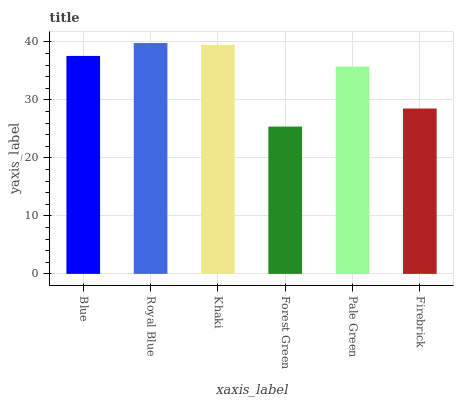Is Forest Green the minimum?
Answer yes or no. Yes. Is Royal Blue the maximum?
Answer yes or no. Yes. Is Khaki the minimum?
Answer yes or no. No. Is Khaki the maximum?
Answer yes or no. No. Is Royal Blue greater than Khaki?
Answer yes or no. Yes. Is Khaki less than Royal Blue?
Answer yes or no. Yes. Is Khaki greater than Royal Blue?
Answer yes or no. No. Is Royal Blue less than Khaki?
Answer yes or no. No. Is Blue the high median?
Answer yes or no. Yes. Is Pale Green the low median?
Answer yes or no. Yes. Is Firebrick the high median?
Answer yes or no. No. Is Blue the low median?
Answer yes or no. No. 